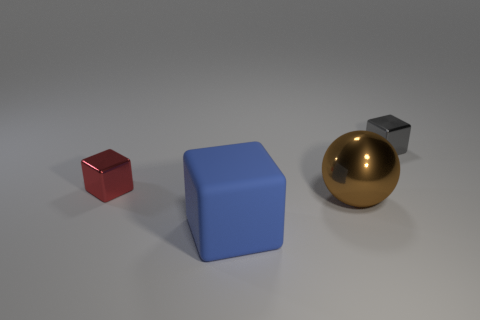Subtract all metal cubes. How many cubes are left? 1 Subtract all red cubes. How many cubes are left? 2 Add 4 small red things. How many objects exist? 8 Subtract all blocks. How many objects are left? 1 Subtract all cyan cubes. Subtract all brown balls. How many cubes are left? 3 Subtract all purple balls. How many green cubes are left? 0 Add 3 small gray cubes. How many small gray cubes are left? 4 Add 2 big brown matte spheres. How many big brown matte spheres exist? 2 Subtract 0 green spheres. How many objects are left? 4 Subtract all big blocks. Subtract all red metal blocks. How many objects are left? 2 